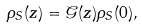Convert formula to latex. <formula><loc_0><loc_0><loc_500><loc_500>\rho _ { S } ( z ) = \mathcal { G } ( z ) \rho _ { S } ( 0 ) ,</formula> 